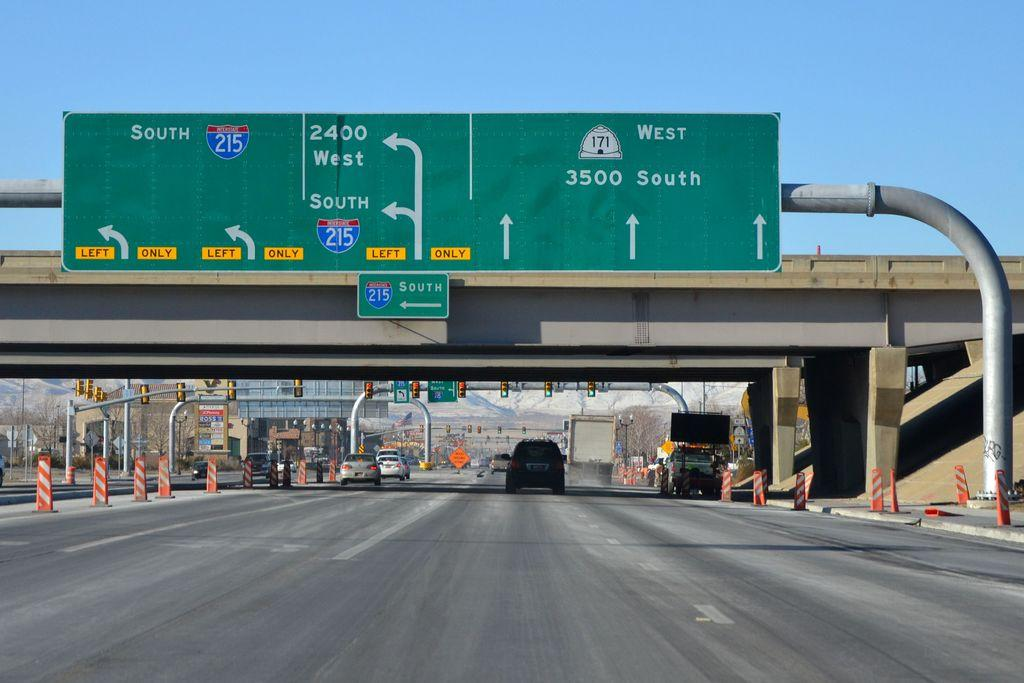<image>
Offer a succinct explanation of the picture presented. A street sign indicates that 3500 South is straight ahead. 